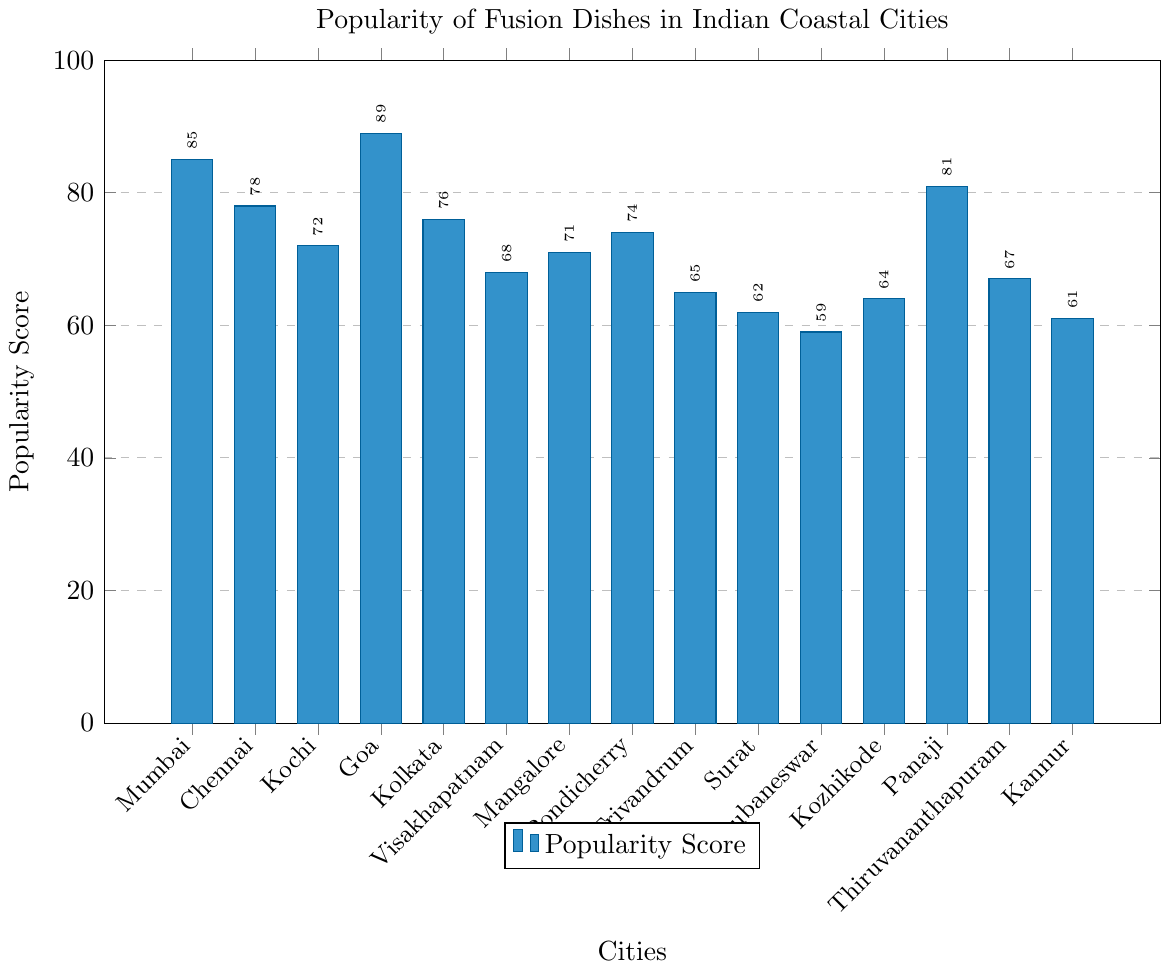What's the most popular city for fusion dishes incorporating coastal flavors? The highest bar indicates the most popular city. The city corresponding to the tallest bar is Goa with a popularity score of 89.
Answer: Goa Which city has the lowest popularity score for fusion dishes incorporating coastal flavors? The smallest bar indicates the least popular city. The city corresponding to the shortest bar is Bhubaneswar with a popularity score of 59.
Answer: Bhubaneswar What is the average popularity score of the listed cities? Sum all popularity scores: 85 + 78 + 72 + 89 + 76 + 68 + 71 + 74 + 65 + 62 + 59 + 64 + 81 + 67 + 61 = 1072. Divide by the number of cities: 1072 / 15 = 71.47
Answer: 71.47 How many cities have a popularity score above 75? Refer to the figure and count the cities with bars reaching above the 75 mark. Those are Mumbai, Chennai, Goa, Kolkata, and Panaji.
Answer: 5 Which two cities have the closest popularity scores? Looking at the height of the bars, Chennai and Kolkata have very close scores with Chennai (78) and Kolkata (76)
Answer: Chennai and Kolkata How many cities have a popularity score below 70? Count the cities with bars below the 70 mark: Visakhapatnam, Trivandrum, Surat, Bhubaneswar, Kozhikode, Thiruvananthapuram, and Kannur
Answer: 7 Which city ranks third in popularity for fusion dishes incorporating coastal flavors? From the figure, Goa is first, Mumbai is second, and Panaji is third
Answer: Panaji What’s the difference in popularity scores between the most and least popular cities? The most popular city Goa has a score of 89, and the least popular city Bhubaneswar has a score of 59. The difference is 89 - 59 = 30
Answer: 30 What is the median popularity score of the listed cities? List the scores in ascending order: 59, 61, 62, 64, 65, 67, 68, 71, 72, 74, 76, 78, 81, 85, 89. The median score is the 8th value in this list, which is 71
Answer: 71 